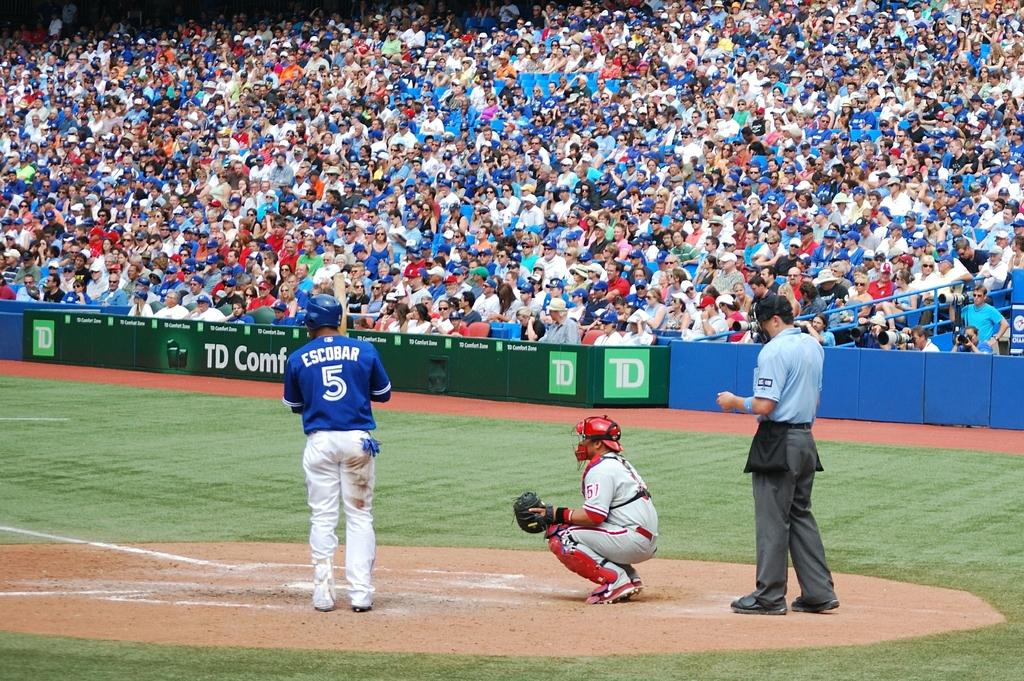Provide a one-sentence caption for the provided image. TD logo in green on a banner on the football field. 